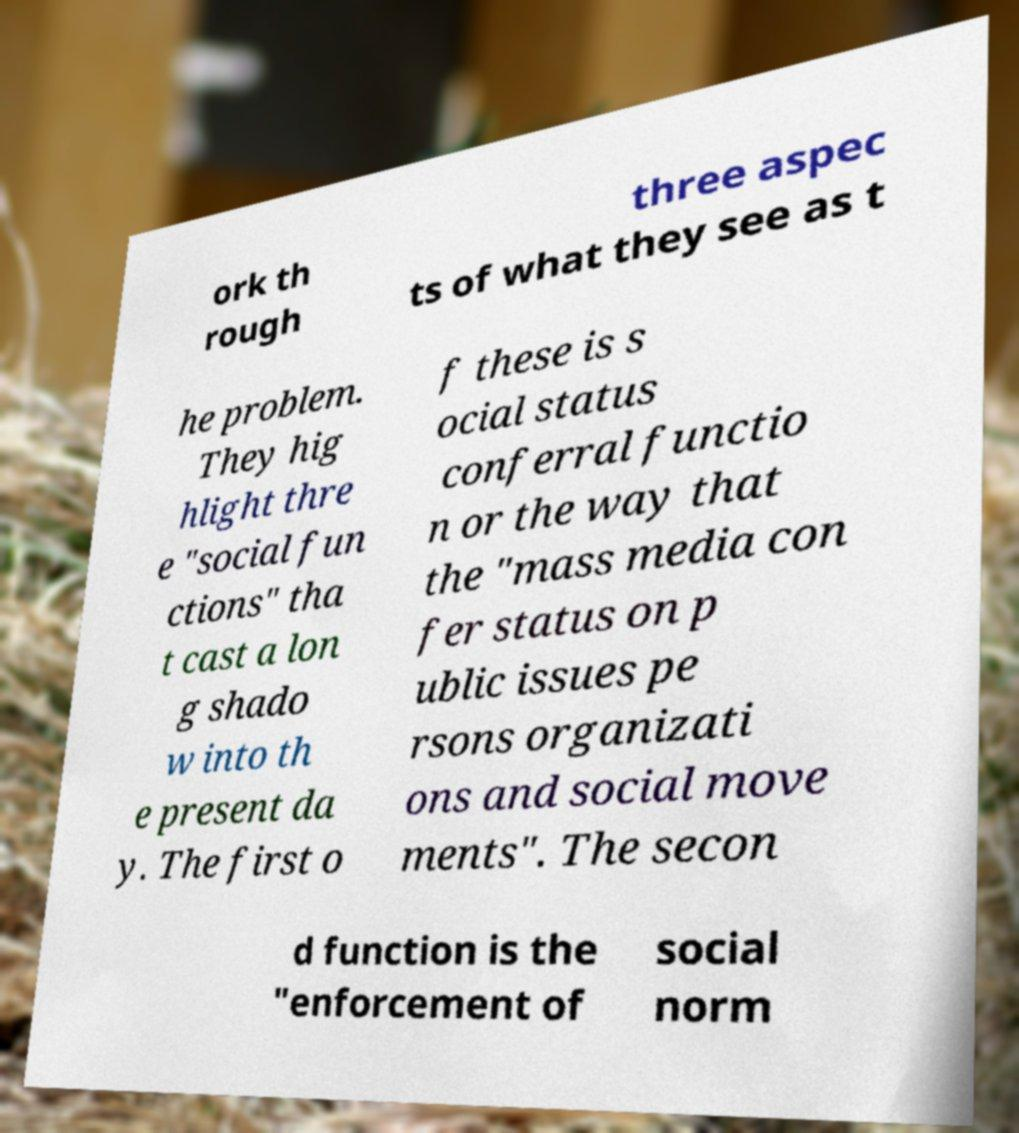Can you accurately transcribe the text from the provided image for me? ork th rough three aspec ts of what they see as t he problem. They hig hlight thre e "social fun ctions" tha t cast a lon g shado w into th e present da y. The first o f these is s ocial status conferral functio n or the way that the "mass media con fer status on p ublic issues pe rsons organizati ons and social move ments". The secon d function is the "enforcement of social norm 